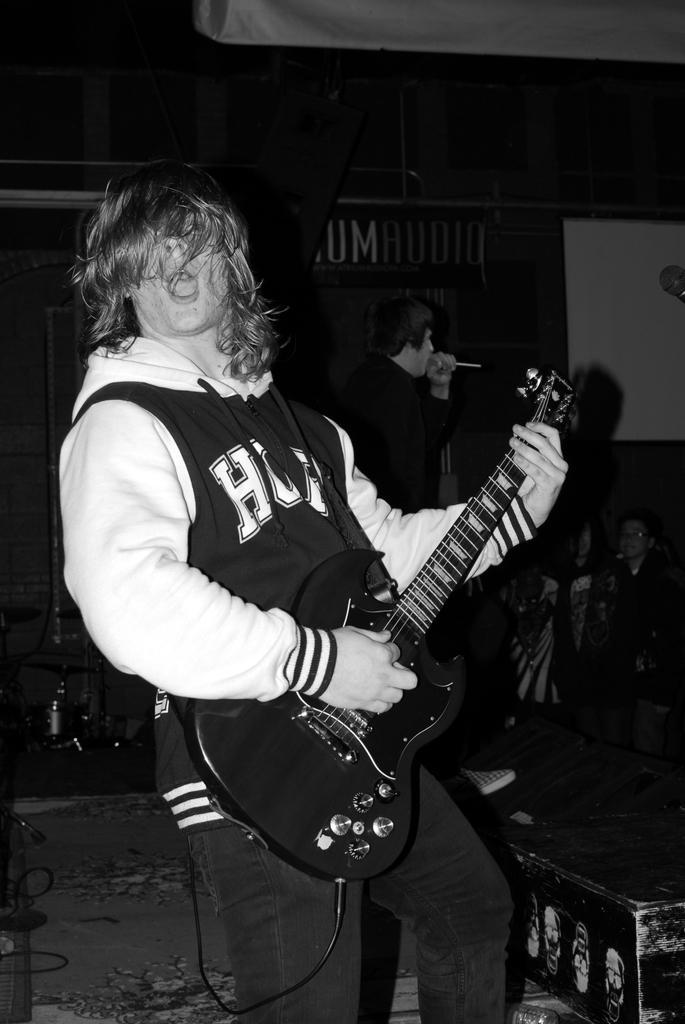Describe this image in one or two sentences. This is a black and white picture. The man is holding a guitar and singing a song and background of the man there is other person holding a microphone and singing a song and a wall. 